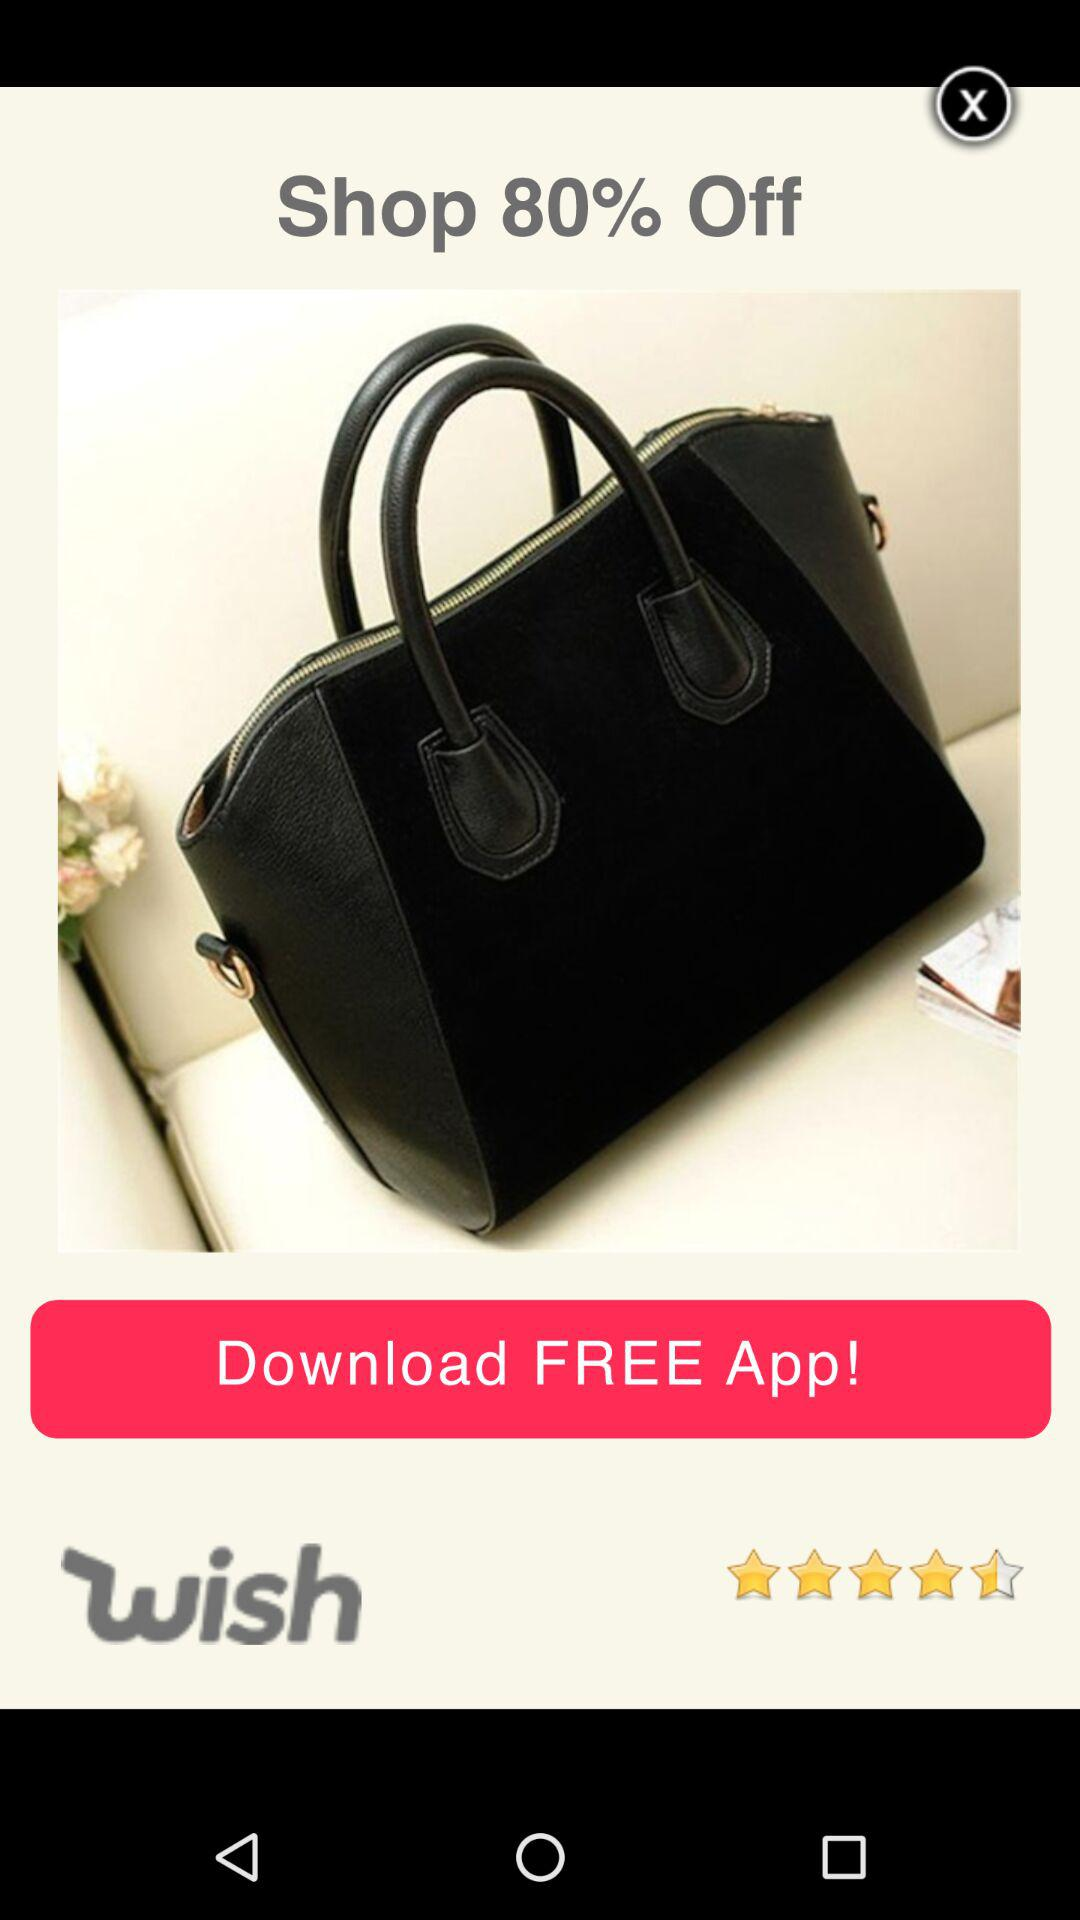How much of a discount is there? There is an 80% discount. 